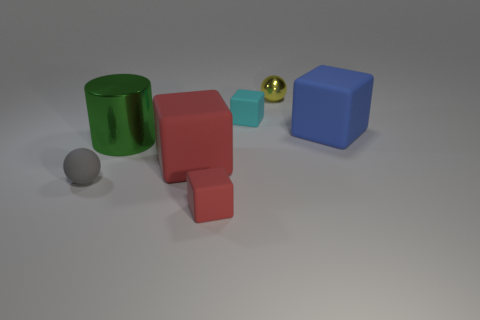Subtract all blue rubber cubes. How many cubes are left? 3 Subtract all cyan cylinders. How many red cubes are left? 2 Subtract all yellow spheres. How many spheres are left? 1 Subtract 2 blocks. How many blocks are left? 2 Add 2 tiny cyan spheres. How many objects exist? 9 Subtract all blocks. How many objects are left? 3 Subtract all blue cylinders. Subtract all blue blocks. How many cylinders are left? 1 Subtract all tiny cyan things. Subtract all tiny purple cylinders. How many objects are left? 6 Add 5 gray balls. How many gray balls are left? 6 Add 4 tiny matte objects. How many tiny matte objects exist? 7 